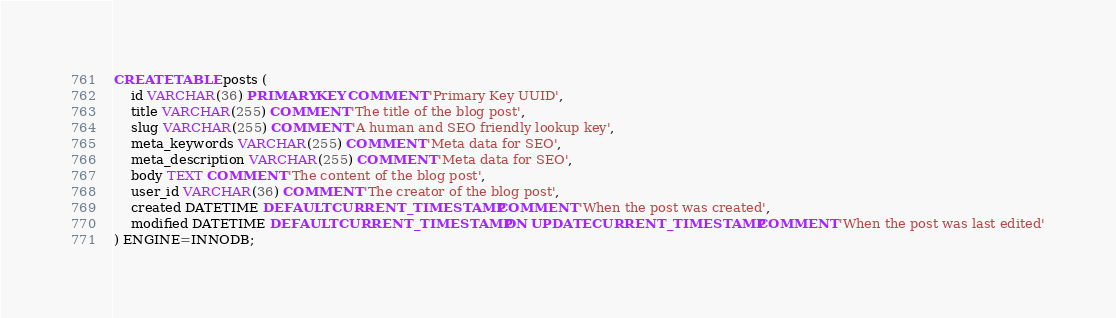<code> <loc_0><loc_0><loc_500><loc_500><_SQL_>CREATE TABLE posts (
    id VARCHAR(36) PRIMARY KEY COMMENT 'Primary Key UUID',
    title VARCHAR(255) COMMENT 'The title of the blog post',
    slug VARCHAR(255) COMMENT 'A human and SEO friendly lookup key',
    meta_keywords VARCHAR(255) COMMENT 'Meta data for SEO',
    meta_description VARCHAR(255) COMMENT 'Meta data for SEO',
    body TEXT COMMENT 'The content of the blog post',
    user_id VARCHAR(36) COMMENT 'The creator of the blog post',
    created DATETIME DEFAULT CURRENT_TIMESTAMP COMMENT 'When the post was created',
    modified DATETIME DEFAULT CURRENT_TIMESTAMP ON UPDATE CURRENT_TIMESTAMP COMMENT 'When the post was last edited'
) ENGINE=INNODB;
</code> 